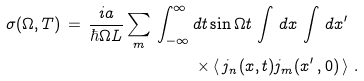<formula> <loc_0><loc_0><loc_500><loc_500>\sigma ( \Omega , T ) \, = \, \frac { i a } { \hbar { \Omega } L } \sum _ { m } \, \int _ { - \infty } ^ { \infty } \, & d t \sin { \Omega t } \, \int \, d x \, \int \, d x ^ { \prime } \\ & \times \left \langle \, j _ { n } ( x , t ) j _ { m } ( x ^ { \prime } \, , 0 ) \, \right \rangle \, .</formula> 